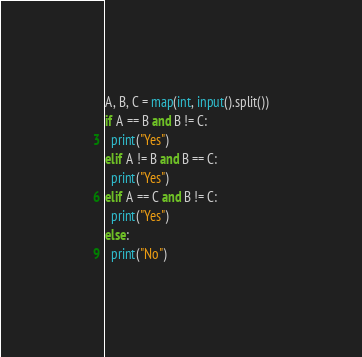Convert code to text. <code><loc_0><loc_0><loc_500><loc_500><_Python_>A, B, C = map(int, input().split())
if A == B and B != C:
  print("Yes")
elif A != B and B == C:
  print("Yes")
elif A == C and B != C:
  print("Yes")
else:
  print("No")</code> 